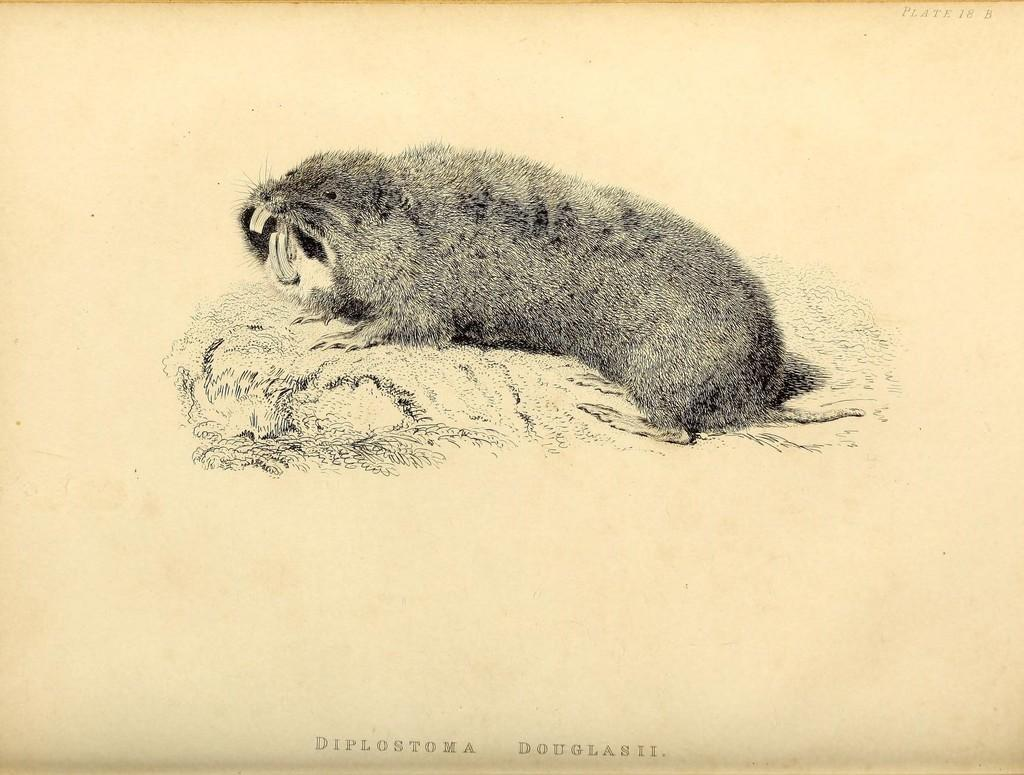What is depicted in the image? There is an art of an animal in the image. Can you see any cobwebs on the animal in the image? There is no mention of cobwebs in the image, and the focus is on the art of an animal, not any real-life elements. 